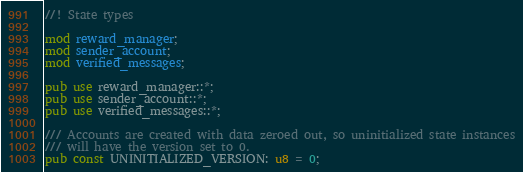Convert code to text. <code><loc_0><loc_0><loc_500><loc_500><_Rust_>//! State types

mod reward_manager;
mod sender_account;
mod verified_messages;

pub use reward_manager::*;
pub use sender_account::*;
pub use verified_messages::*;

/// Accounts are created with data zeroed out, so uninitialized state instances
/// will have the version set to 0.
pub const UNINITIALIZED_VERSION: u8 = 0;
</code> 